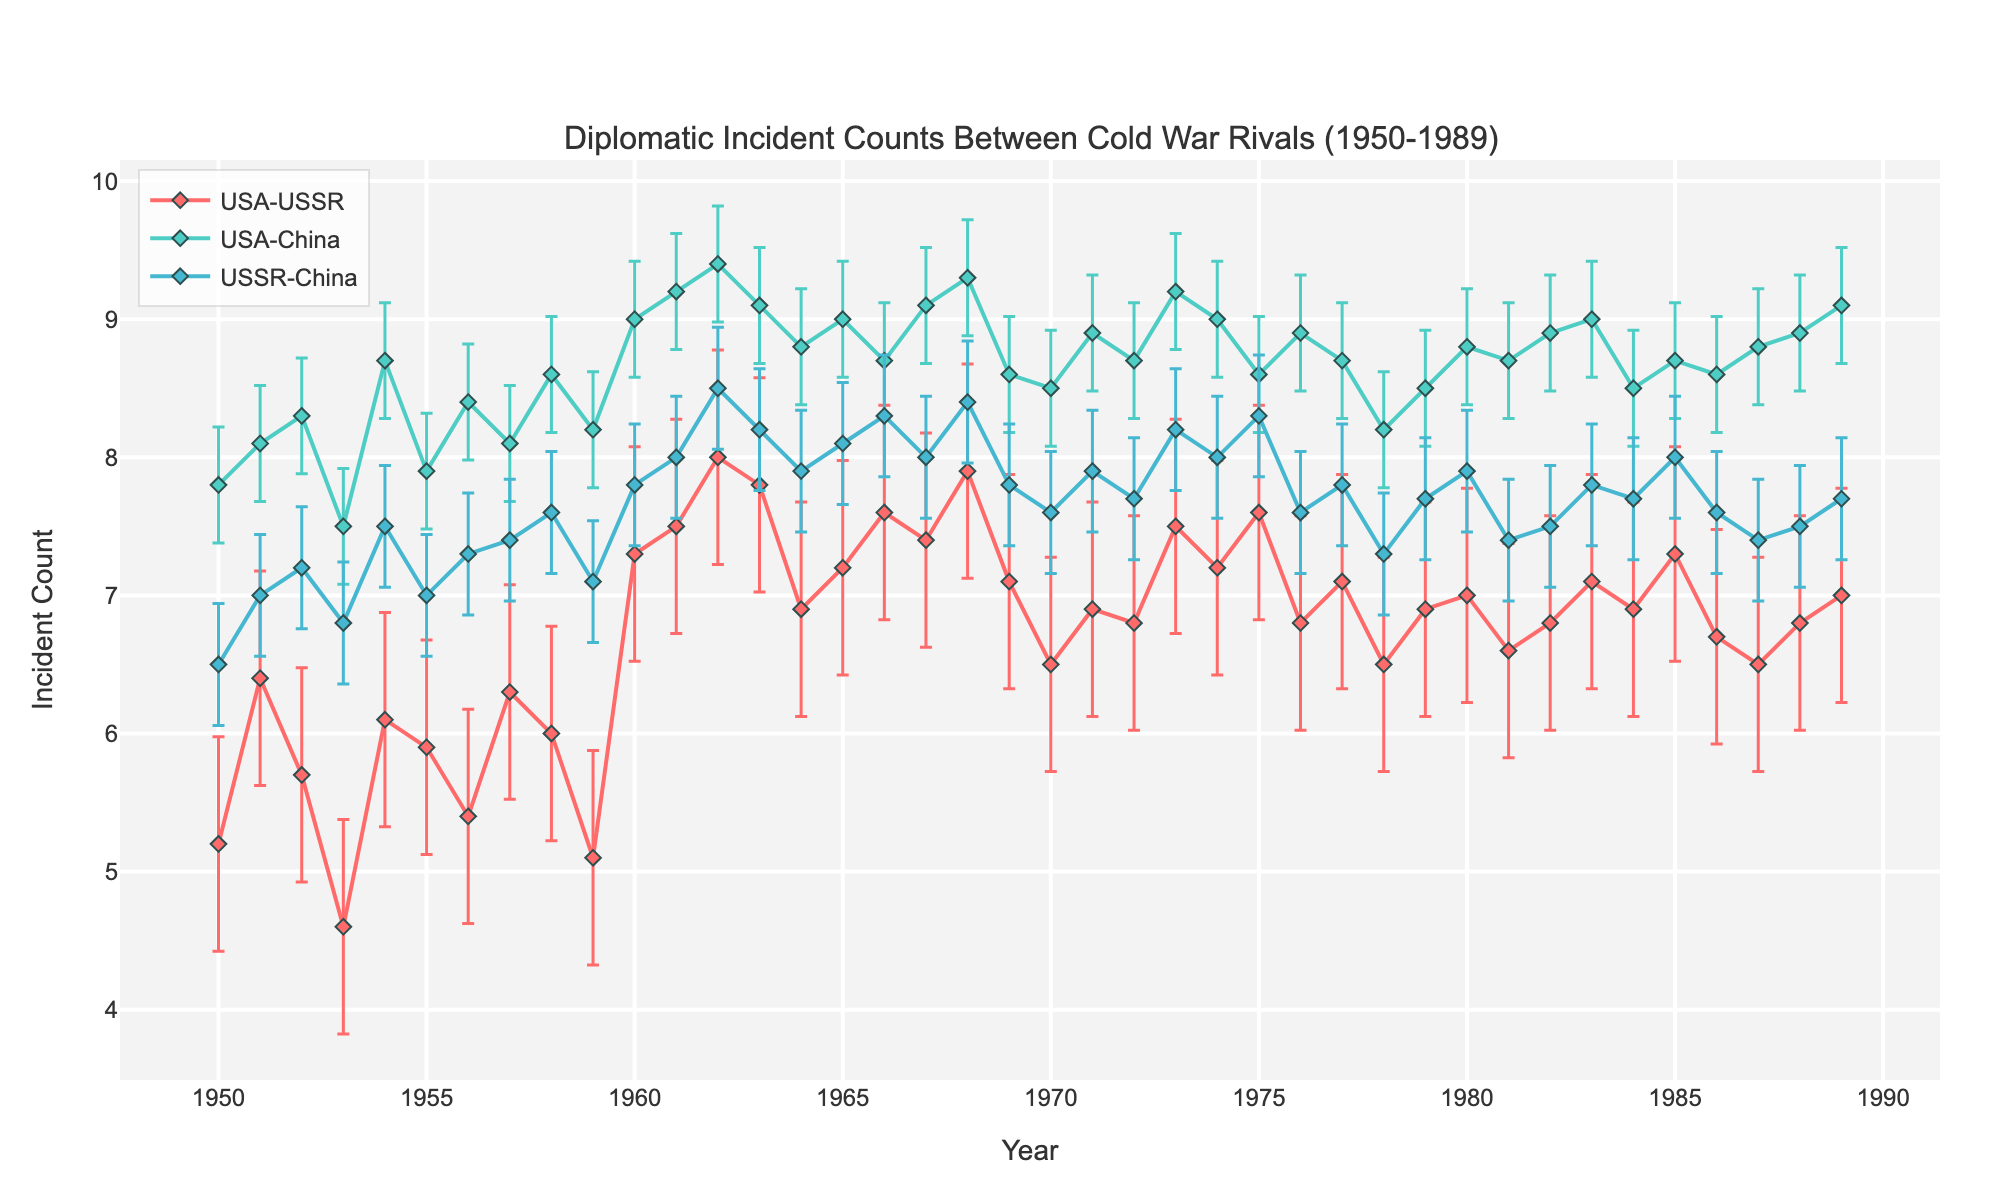what is the title of the figure? The title of the figure is typically located at the top and gives an overview of the data being presented. In this case, the title describes the subject of the plot clearly.
Answer: Diplomatic Incident Counts Between Cold War Rivals (1950-1989) how many different rival pairs are represented in the plot? To determine this, count the number of distinct lines or markers, usually distinguished by different colors and labels, representing different data series.
Answer: 3 what is the y-axis label? The y-axis label is generally positioned vertically along the y-axis and describes the measurement unit for the plotted data. Here it indicates what is being measured.
Answer: Incident Count during which year did USA-USSR have the highest diplomatic incident count? Look for the highest point on the USA-USSR line and then match it to the corresponding year on the x-axis.
Answer: 1962 which pair had the most consistent number of incidents over the years, based on error bars? Consistency can be inferred by examining the length of the error bars. Shorter error bars indicate less variation and hence more consistency.
Answer: USA-USSR how does the incident count for USA-China in 1965 compare with that in 1985? Find the markers for USA-China in the years 1965 and 1985 and compare their y-values to see which is higher.
Answer: Lower in 1965 than in 1985 calculate the average diplomatic incident count for USSR-China over the entire period. Sum up all the yearly incident counts for USSR-China and divide by the number of years (40). Summing (6.5 + 7.0 + ... + 7.7) = 316.4, so (316.4/40).
Answer: 7.91 which cold war rival pair showed the largest increase in annual incidents from 1950 to 1989? Calculate the difference in counts from 1989 to 1950 for each pair and see which one has the largest positive change. For USA-USSR (7.0 - 5.2 = 1.8), USA-China (9.1 - 7.8 = 1.3), USSR-China (7.7 - 6.5 = 1.2), the largest increase is 1.8.
Answer: USA-USSR what can be inferred about the stability of diplomatic incidents involving USA and China over the analyzed period? Analyze the trend and error bars for the USA-China line. If it shows a steady pattern with smaller error bars, it indicates stability.
Answer: Relatively stable with minor fluctuations 